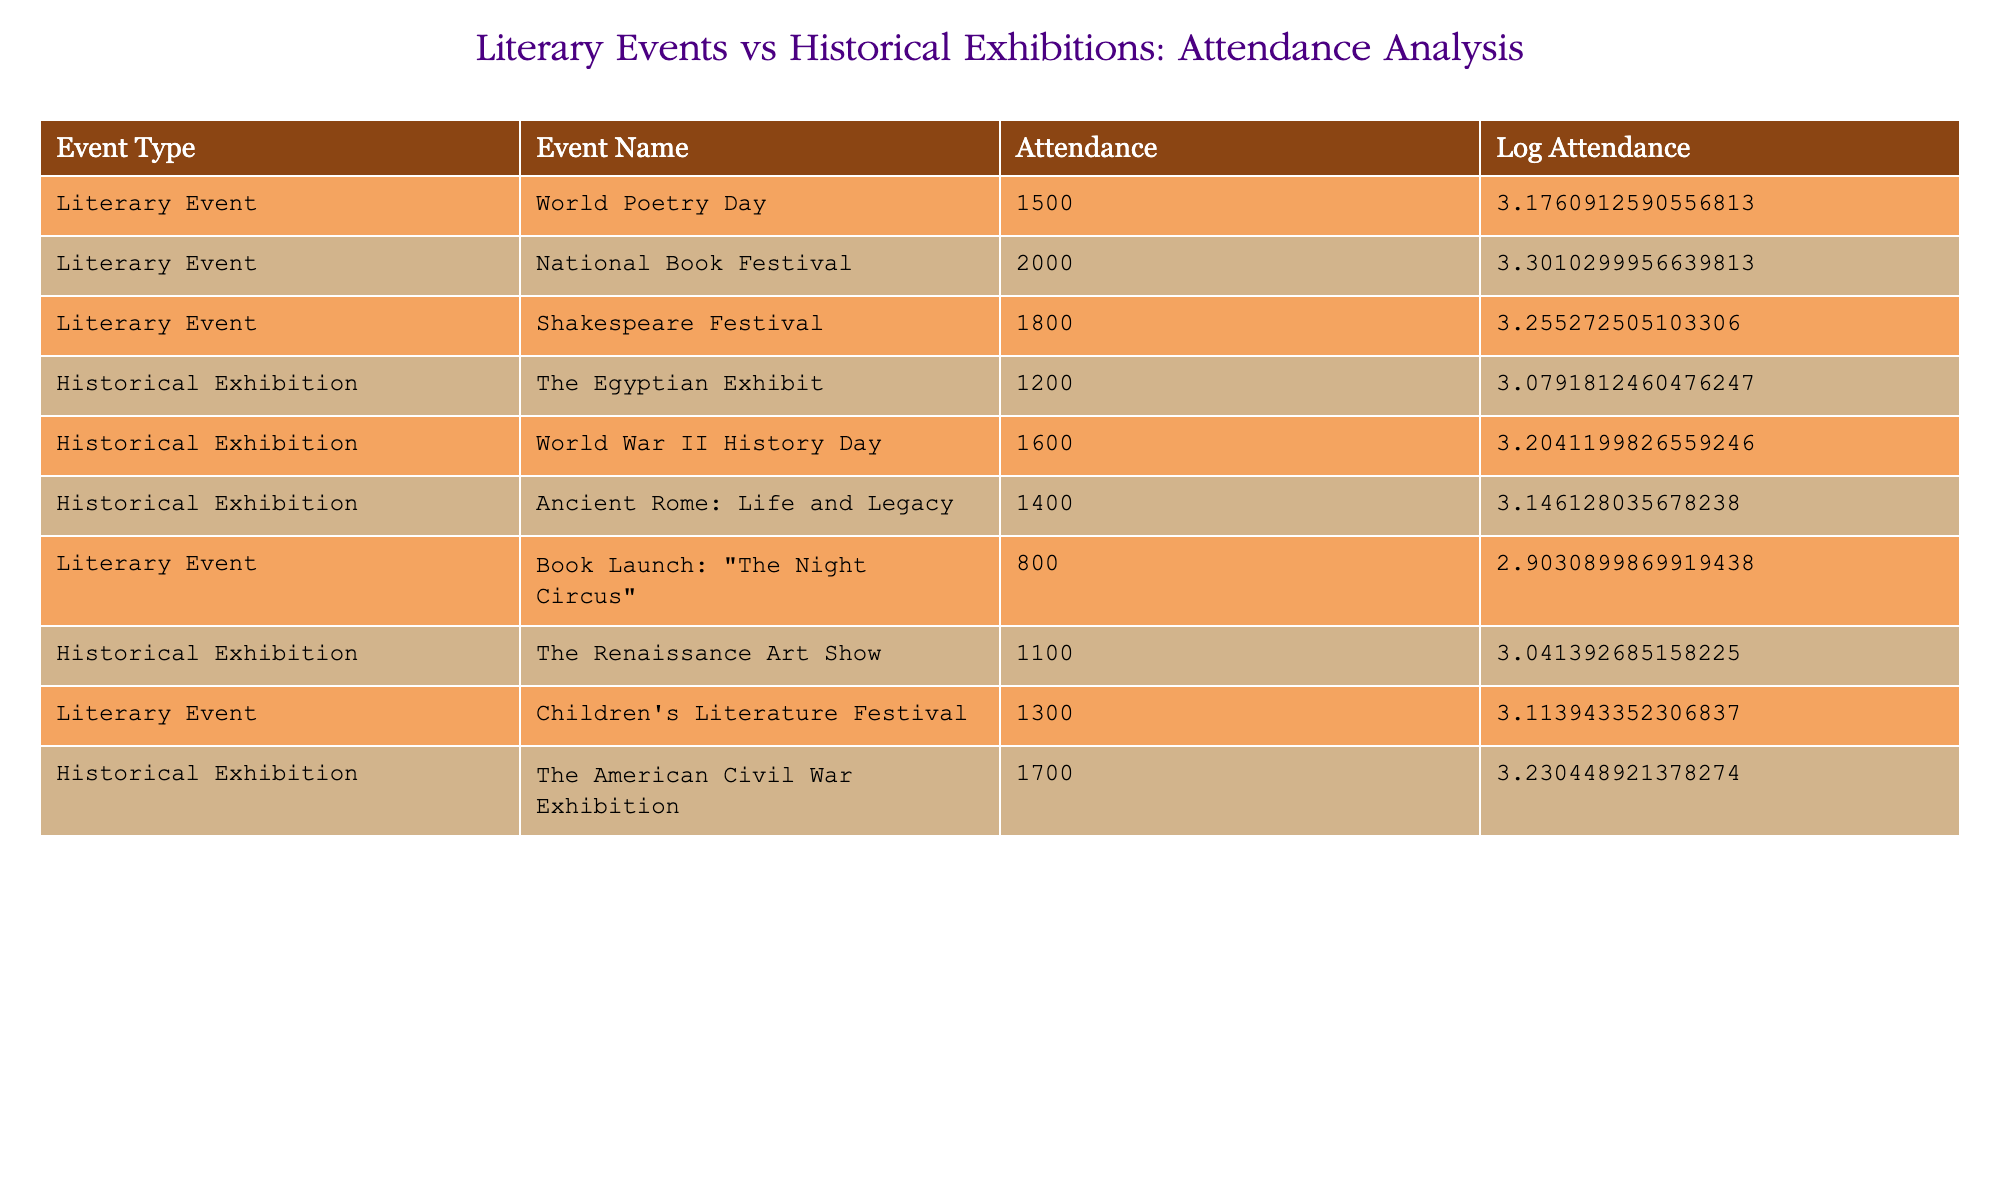What is the attendance for the Shakespeare Festival? The attendance for the Shakespeare Festival is listed directly in the table under the "Attendance" column corresponding to the "Shakespeare Festival" event.
Answer: 1800 What is the total attendance for all historical exhibitions? To find the total attendance for historical exhibitions, sum the attendance values for all events under this category: 1200 (The Egyptian Exhibit) + 1600 (World War II History Day) + 1400 (Ancient Rome: Life and Legacy) + 1100 (The Renaissance Art Show) + 1700 (The American Civil War Exhibition) = 8200.
Answer: 8200 Is the attendance for the National Book Festival greater than that of the Children's Literature Festival? Compare the attendance values for the two events: National Book Festival has 2000 and Children's Literature Festival has 1300. Since 2000 is greater than 1300, the statement is true.
Answer: Yes What is the average attendance for all literary events? First, list the attendance figures for all literary events: 1500 + 2000 + 1800 + 800 + 1300 = 8000. Then, divide by the number of literary events (5): 8000 / 5 = 1600.
Answer: 1600 Which event recorded the lowest attendance? Look for the event with the minimum attendance value in the table: The lowest attendance is for the Book Launch: "The Night Circus" with 800 attendees.
Answer: Book Launch: "The Night Circus" What is the difference in attendance between the World Poetry Day and the Renaissance Art Show? The attendance for World Poetry Day is 1500 and for the Renaissance Art Show is 1100. To find the difference, subtract the attendance of the Renaissance Art Show from that of World Poetry Day: 1500 - 1100 = 400.
Answer: 400 What is the total attendance for literary events that have more than 1500 participants? Identify the literary events with attendance greater than 1500: National Book Festival (2000) and Shakespeare Festival (1800). Add them together: 2000 + 1800 = 3800.
Answer: 3800 Are all historical exhibitions attended by at least 1000 people? Examine the attendance figures for each historical exhibition: 1200, 1600, 1400, 1100, and 1700. All values are above 1000, so the statement is true.
Answer: Yes 